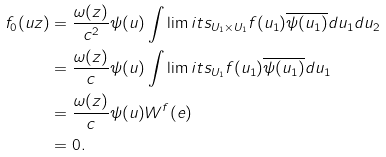<formula> <loc_0><loc_0><loc_500><loc_500>f _ { 0 } ( u z ) & = \frac { \omega ( z ) } { c ^ { 2 } } \psi ( u ) \int \lim i t s _ { U _ { 1 } \times U _ { 1 } } f ( u _ { 1 } ) \overline { \psi ( u _ { 1 } ) } d u _ { 1 } d u _ { 2 } \\ & = \frac { \omega ( z ) } { c } \psi ( u ) \int \lim i t s _ { U _ { 1 } } f ( u _ { 1 } ) \overline { \psi ( u _ { 1 } ) } d u _ { 1 } \\ & = \frac { \omega ( z ) } { c } \psi ( u ) W ^ { f } ( e ) \\ & = 0 .</formula> 